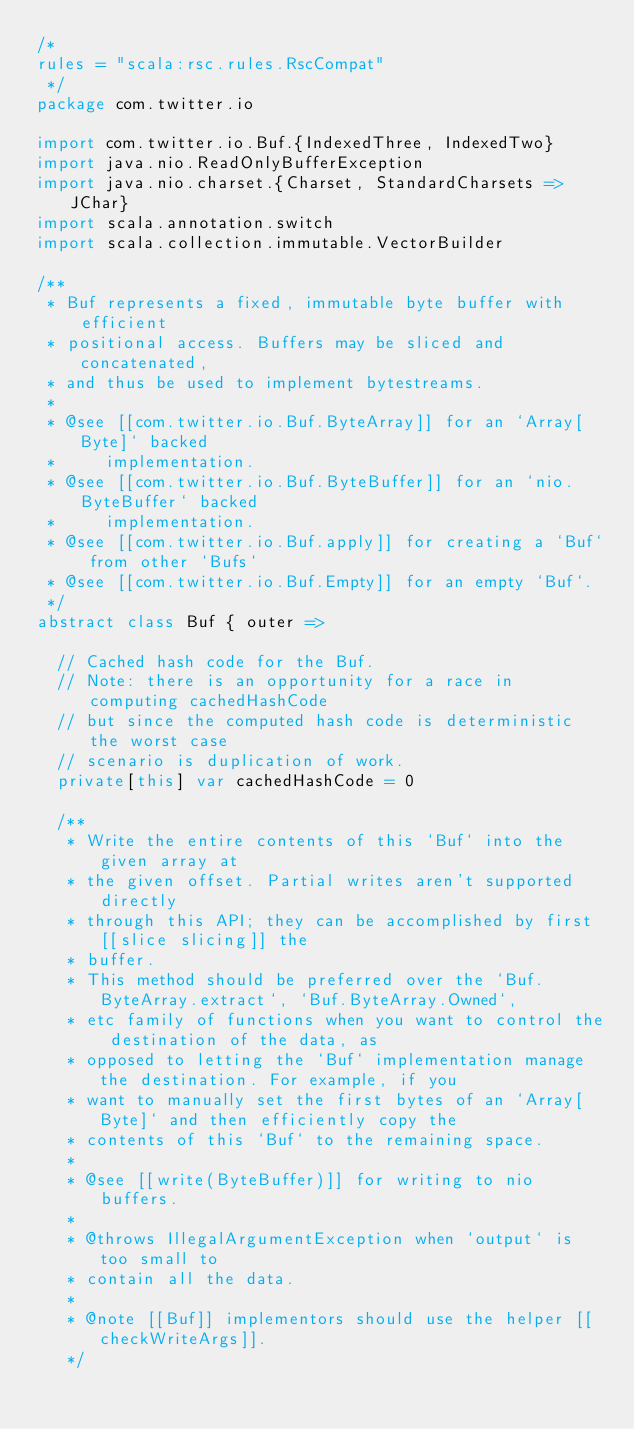Convert code to text. <code><loc_0><loc_0><loc_500><loc_500><_Scala_>/*
rules = "scala:rsc.rules.RscCompat"
 */
package com.twitter.io

import com.twitter.io.Buf.{IndexedThree, IndexedTwo}
import java.nio.ReadOnlyBufferException
import java.nio.charset.{Charset, StandardCharsets => JChar}
import scala.annotation.switch
import scala.collection.immutable.VectorBuilder

/**
 * Buf represents a fixed, immutable byte buffer with efficient
 * positional access. Buffers may be sliced and concatenated,
 * and thus be used to implement bytestreams.
 *
 * @see [[com.twitter.io.Buf.ByteArray]] for an `Array[Byte]` backed
 *     implementation.
 * @see [[com.twitter.io.Buf.ByteBuffer]] for an `nio.ByteBuffer` backed
 *     implementation.
 * @see [[com.twitter.io.Buf.apply]] for creating a `Buf` from other `Bufs`
 * @see [[com.twitter.io.Buf.Empty]] for an empty `Buf`.
 */
abstract class Buf { outer =>

  // Cached hash code for the Buf.
  // Note: there is an opportunity for a race in computing cachedHashCode
  // but since the computed hash code is deterministic the worst case
  // scenario is duplication of work.
  private[this] var cachedHashCode = 0

  /**
   * Write the entire contents of this `Buf` into the given array at
   * the given offset. Partial writes aren't supported directly
   * through this API; they can be accomplished by first [[slice slicing]] the
   * buffer.
   * This method should be preferred over the `Buf.ByteArray.extract`, `Buf.ByteArray.Owned`,
   * etc family of functions when you want to control the destination of the data, as
   * opposed to letting the `Buf` implementation manage the destination. For example, if you
   * want to manually set the first bytes of an `Array[Byte]` and then efficiently copy the
   * contents of this `Buf` to the remaining space.
   *
   * @see [[write(ByteBuffer)]] for writing to nio buffers.
   *
   * @throws IllegalArgumentException when `output` is too small to
   * contain all the data.
   *
   * @note [[Buf]] implementors should use the helper [[checkWriteArgs]].
   */</code> 